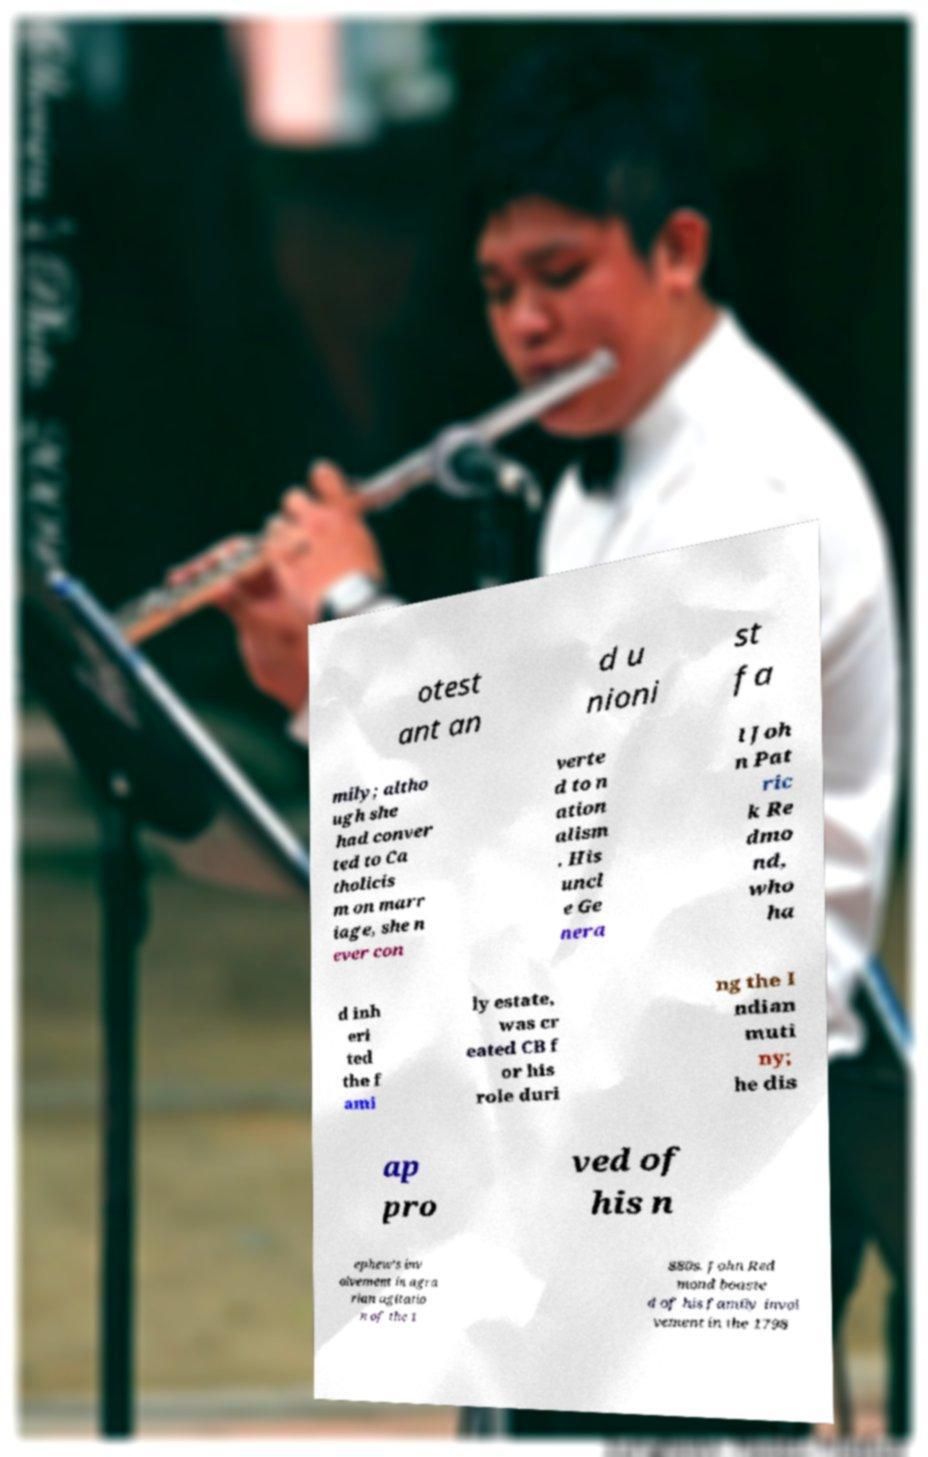I need the written content from this picture converted into text. Can you do that? otest ant an d u nioni st fa mily; altho ugh she had conver ted to Ca tholicis m on marr iage, she n ever con verte d to n ation alism . His uncl e Ge nera l Joh n Pat ric k Re dmo nd, who ha d inh eri ted the f ami ly estate, was cr eated CB f or his role duri ng the I ndian muti ny; he dis ap pro ved of his n ephew's inv olvement in agra rian agitatio n of the 1 880s. John Red mond boaste d of his family invol vement in the 1798 